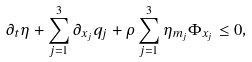<formula> <loc_0><loc_0><loc_500><loc_500>\partial _ { t } \eta + \sum _ { j = 1 } ^ { 3 } \partial _ { x _ { j } } q _ { j } + \rho \sum _ { j = 1 } ^ { 3 } \eta _ { m _ { j } } \Phi _ { x _ { j } } \leq 0 ,</formula> 